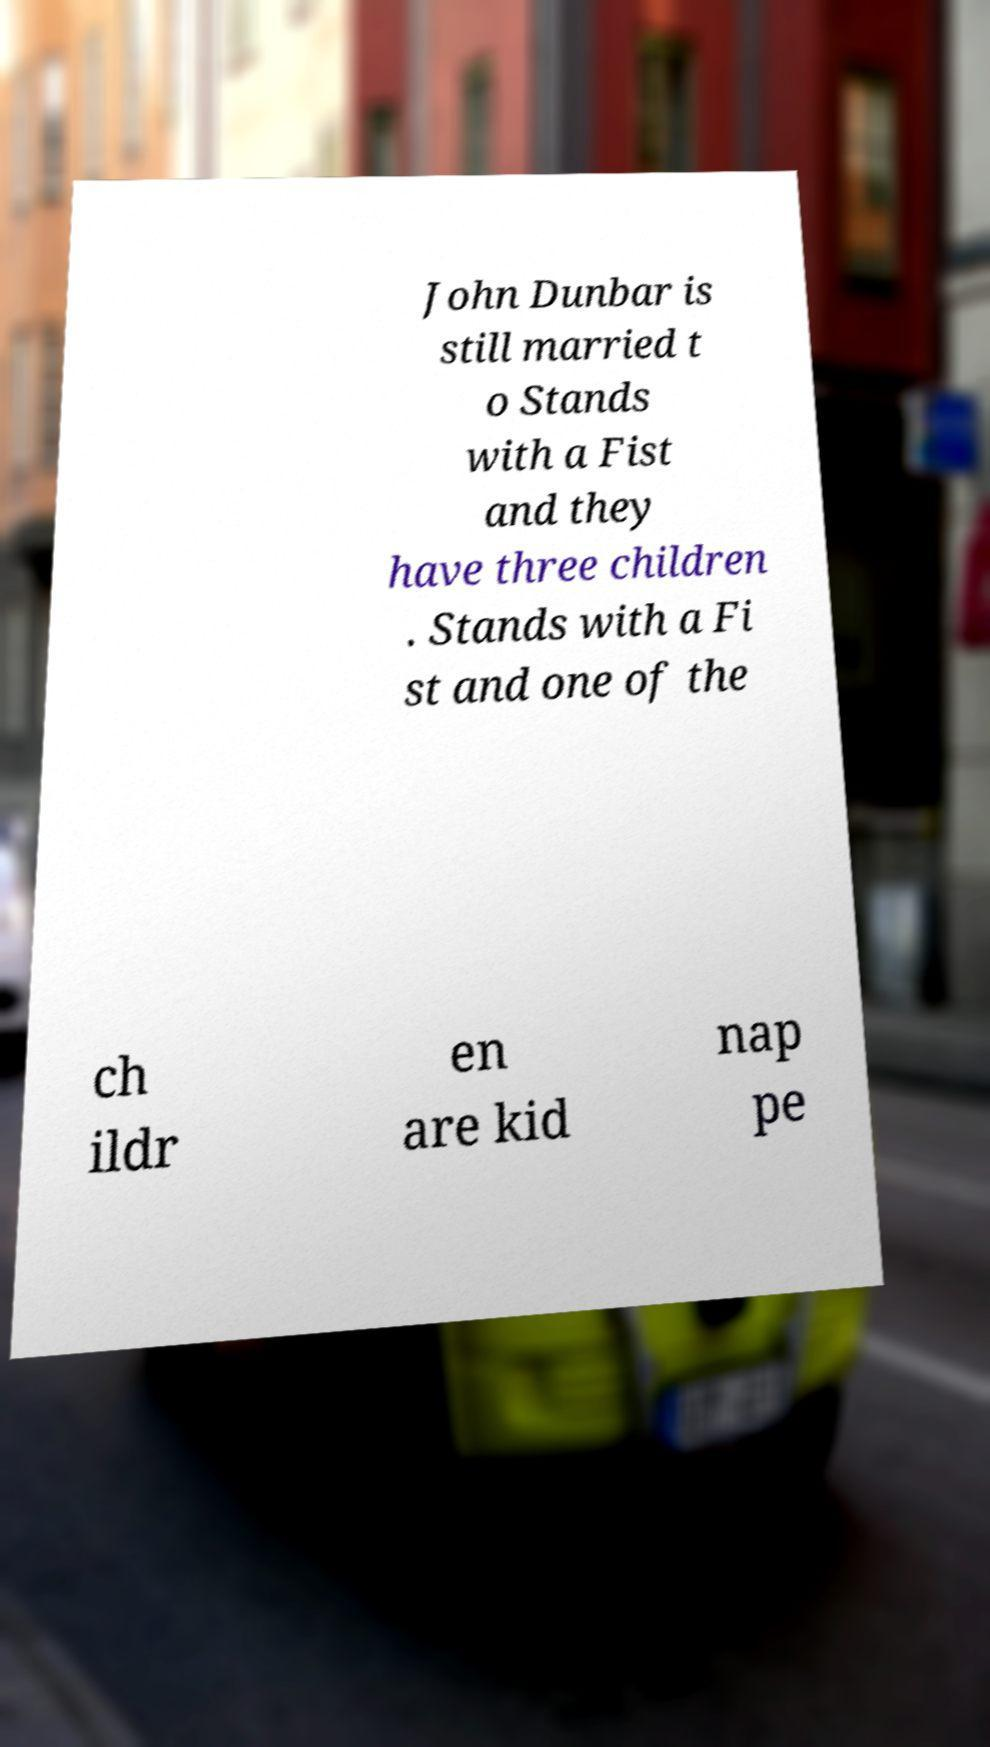What messages or text are displayed in this image? I need them in a readable, typed format. John Dunbar is still married t o Stands with a Fist and they have three children . Stands with a Fi st and one of the ch ildr en are kid nap pe 